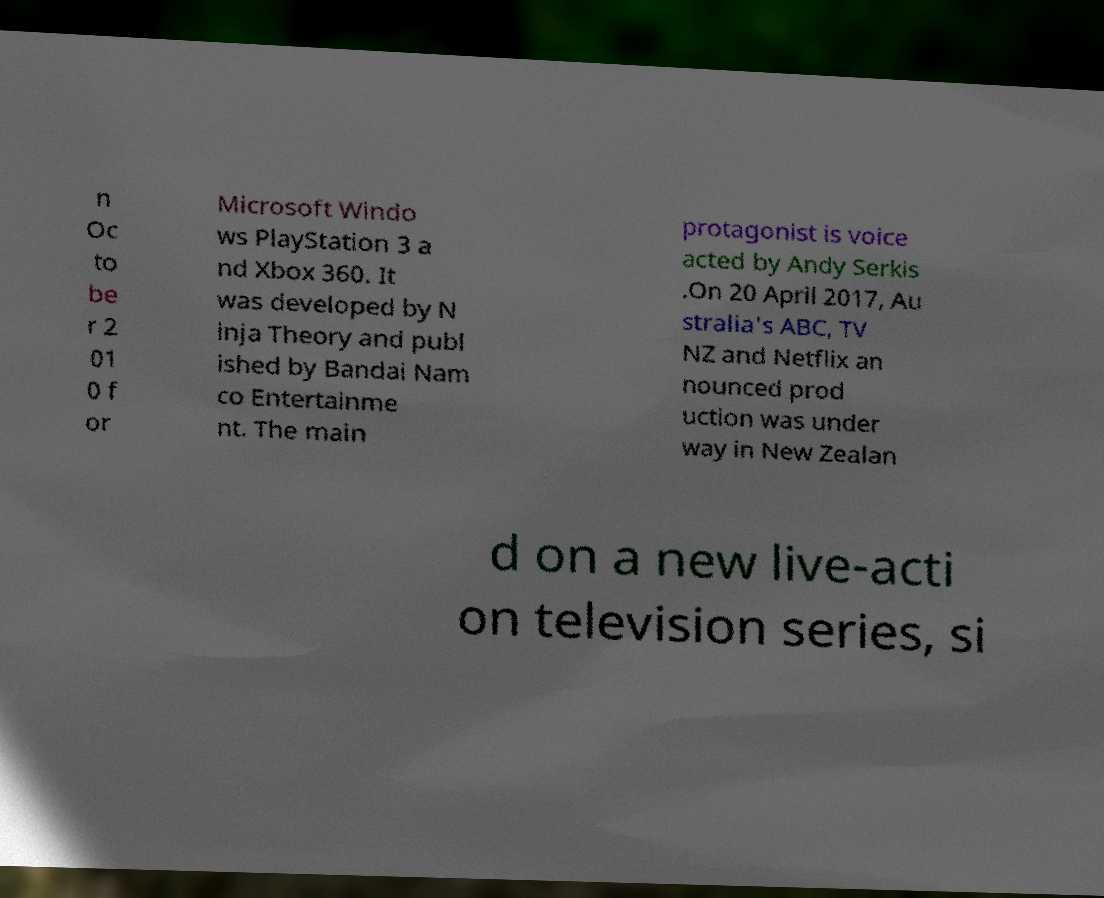I need the written content from this picture converted into text. Can you do that? n Oc to be r 2 01 0 f or Microsoft Windo ws PlayStation 3 a nd Xbox 360. It was developed by N inja Theory and publ ished by Bandai Nam co Entertainme nt. The main protagonist is voice acted by Andy Serkis .On 20 April 2017, Au stralia's ABC, TV NZ and Netflix an nounced prod uction was under way in New Zealan d on a new live-acti on television series, si 